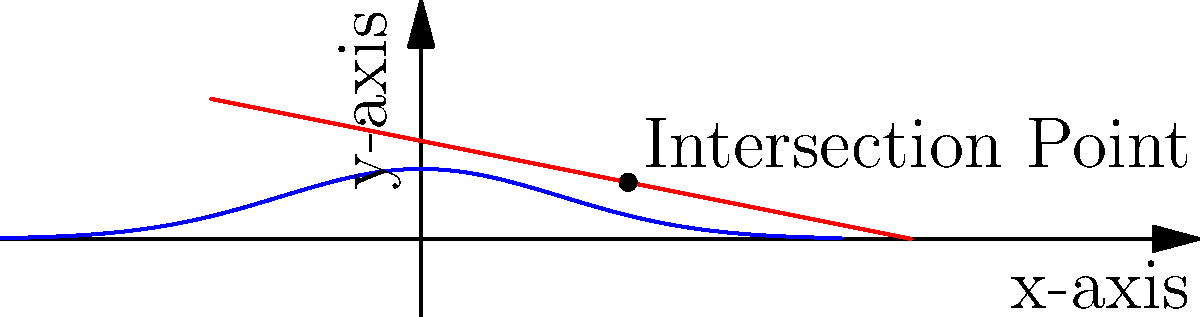Consider a curved surface designed for stealth technology, where the absorption of electromagnetic waves is modeled by the function $A(x) = 0.5e^{-x^2/2}$, and the reflection is given by $R(x) = 0.7 - 0.2x$. At what point do the absorption and reflection curves intersect? Round your answer to two decimal places. To find the intersection point, we need to solve the equation:

$A(x) = R(x)$

$0.5e^{-x^2/2} = 0.7 - 0.2x$

This equation cannot be solved analytically, so we need to use a numerical method. We can use the Newton-Raphson method:

1) Define $f(x) = 0.5e^{-x^2/2} - 0.7 + 0.2x$
2) Its derivative is $f'(x) = -0.5xe^{-x^2/2} + 0.2$
3) Start with an initial guess, say $x_0 = 1$
4) Apply the iteration formula: $x_{n+1} = x_n - \frac{f(x_n)}{f'(x_n)}$

After a few iterations, we converge to $x \approx 1.48$.

To verify, we can calculate:
$A(1.48) \approx 0.5e^{-1.48^2/2} \approx 0.404$
$R(1.48) \approx 0.7 - 0.2(1.48) \approx 0.404$

Therefore, the intersection point is approximately (1.48, 0.404).
Answer: (1.48, 0.404) 